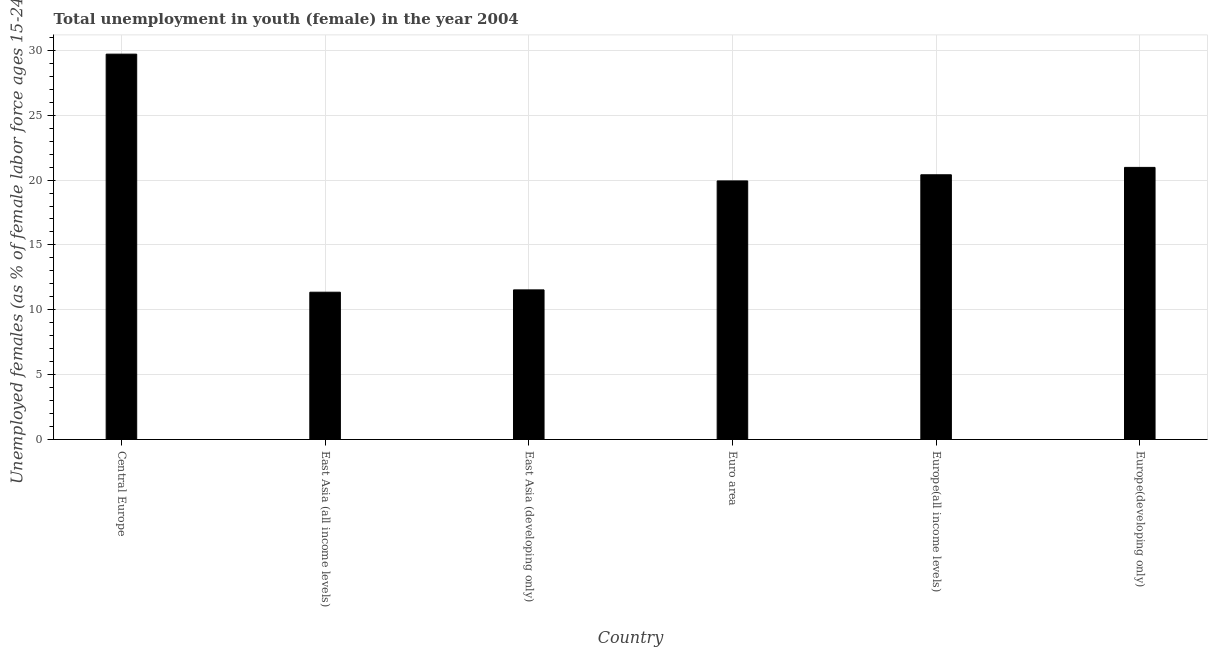What is the title of the graph?
Your answer should be very brief. Total unemployment in youth (female) in the year 2004. What is the label or title of the X-axis?
Ensure brevity in your answer.  Country. What is the label or title of the Y-axis?
Make the answer very short. Unemployed females (as % of female labor force ages 15-24). What is the unemployed female youth population in East Asia (developing only)?
Provide a succinct answer. 11.54. Across all countries, what is the maximum unemployed female youth population?
Your answer should be compact. 29.71. Across all countries, what is the minimum unemployed female youth population?
Provide a short and direct response. 11.36. In which country was the unemployed female youth population maximum?
Your answer should be compact. Central Europe. In which country was the unemployed female youth population minimum?
Offer a terse response. East Asia (all income levels). What is the sum of the unemployed female youth population?
Provide a short and direct response. 113.92. What is the difference between the unemployed female youth population in East Asia (developing only) and Europe(developing only)?
Offer a terse response. -9.44. What is the average unemployed female youth population per country?
Your answer should be compact. 18.99. What is the median unemployed female youth population?
Make the answer very short. 20.17. In how many countries, is the unemployed female youth population greater than 20 %?
Your response must be concise. 3. What is the ratio of the unemployed female youth population in East Asia (developing only) to that in Europe(developing only)?
Make the answer very short. 0.55. Is the difference between the unemployed female youth population in Euro area and Europe(developing only) greater than the difference between any two countries?
Provide a short and direct response. No. What is the difference between the highest and the second highest unemployed female youth population?
Provide a short and direct response. 8.73. What is the difference between the highest and the lowest unemployed female youth population?
Your answer should be very brief. 18.35. In how many countries, is the unemployed female youth population greater than the average unemployed female youth population taken over all countries?
Provide a succinct answer. 4. How many bars are there?
Make the answer very short. 6. Are all the bars in the graph horizontal?
Your answer should be very brief. No. How many countries are there in the graph?
Keep it short and to the point. 6. What is the difference between two consecutive major ticks on the Y-axis?
Your response must be concise. 5. Are the values on the major ticks of Y-axis written in scientific E-notation?
Make the answer very short. No. What is the Unemployed females (as % of female labor force ages 15-24) of Central Europe?
Keep it short and to the point. 29.71. What is the Unemployed females (as % of female labor force ages 15-24) of East Asia (all income levels)?
Keep it short and to the point. 11.36. What is the Unemployed females (as % of female labor force ages 15-24) in East Asia (developing only)?
Offer a very short reply. 11.54. What is the Unemployed females (as % of female labor force ages 15-24) in Euro area?
Your response must be concise. 19.94. What is the Unemployed females (as % of female labor force ages 15-24) of Europe(all income levels)?
Offer a very short reply. 20.41. What is the Unemployed females (as % of female labor force ages 15-24) in Europe(developing only)?
Give a very brief answer. 20.98. What is the difference between the Unemployed females (as % of female labor force ages 15-24) in Central Europe and East Asia (all income levels)?
Your response must be concise. 18.35. What is the difference between the Unemployed females (as % of female labor force ages 15-24) in Central Europe and East Asia (developing only)?
Make the answer very short. 18.17. What is the difference between the Unemployed females (as % of female labor force ages 15-24) in Central Europe and Euro area?
Your answer should be compact. 9.77. What is the difference between the Unemployed females (as % of female labor force ages 15-24) in Central Europe and Europe(all income levels)?
Your answer should be very brief. 9.3. What is the difference between the Unemployed females (as % of female labor force ages 15-24) in Central Europe and Europe(developing only)?
Provide a succinct answer. 8.73. What is the difference between the Unemployed females (as % of female labor force ages 15-24) in East Asia (all income levels) and East Asia (developing only)?
Give a very brief answer. -0.18. What is the difference between the Unemployed females (as % of female labor force ages 15-24) in East Asia (all income levels) and Euro area?
Offer a terse response. -8.58. What is the difference between the Unemployed females (as % of female labor force ages 15-24) in East Asia (all income levels) and Europe(all income levels)?
Keep it short and to the point. -9.05. What is the difference between the Unemployed females (as % of female labor force ages 15-24) in East Asia (all income levels) and Europe(developing only)?
Keep it short and to the point. -9.62. What is the difference between the Unemployed females (as % of female labor force ages 15-24) in East Asia (developing only) and Euro area?
Make the answer very short. -8.4. What is the difference between the Unemployed females (as % of female labor force ages 15-24) in East Asia (developing only) and Europe(all income levels)?
Offer a very short reply. -8.87. What is the difference between the Unemployed females (as % of female labor force ages 15-24) in East Asia (developing only) and Europe(developing only)?
Your answer should be very brief. -9.44. What is the difference between the Unemployed females (as % of female labor force ages 15-24) in Euro area and Europe(all income levels)?
Offer a very short reply. -0.47. What is the difference between the Unemployed females (as % of female labor force ages 15-24) in Euro area and Europe(developing only)?
Keep it short and to the point. -1.04. What is the difference between the Unemployed females (as % of female labor force ages 15-24) in Europe(all income levels) and Europe(developing only)?
Keep it short and to the point. -0.57. What is the ratio of the Unemployed females (as % of female labor force ages 15-24) in Central Europe to that in East Asia (all income levels)?
Offer a terse response. 2.62. What is the ratio of the Unemployed females (as % of female labor force ages 15-24) in Central Europe to that in East Asia (developing only)?
Offer a very short reply. 2.58. What is the ratio of the Unemployed females (as % of female labor force ages 15-24) in Central Europe to that in Euro area?
Offer a very short reply. 1.49. What is the ratio of the Unemployed females (as % of female labor force ages 15-24) in Central Europe to that in Europe(all income levels)?
Give a very brief answer. 1.46. What is the ratio of the Unemployed females (as % of female labor force ages 15-24) in Central Europe to that in Europe(developing only)?
Give a very brief answer. 1.42. What is the ratio of the Unemployed females (as % of female labor force ages 15-24) in East Asia (all income levels) to that in East Asia (developing only)?
Ensure brevity in your answer.  0.98. What is the ratio of the Unemployed females (as % of female labor force ages 15-24) in East Asia (all income levels) to that in Euro area?
Provide a short and direct response. 0.57. What is the ratio of the Unemployed females (as % of female labor force ages 15-24) in East Asia (all income levels) to that in Europe(all income levels)?
Offer a terse response. 0.56. What is the ratio of the Unemployed females (as % of female labor force ages 15-24) in East Asia (all income levels) to that in Europe(developing only)?
Offer a very short reply. 0.54. What is the ratio of the Unemployed females (as % of female labor force ages 15-24) in East Asia (developing only) to that in Euro area?
Give a very brief answer. 0.58. What is the ratio of the Unemployed females (as % of female labor force ages 15-24) in East Asia (developing only) to that in Europe(all income levels)?
Your response must be concise. 0.56. What is the ratio of the Unemployed females (as % of female labor force ages 15-24) in East Asia (developing only) to that in Europe(developing only)?
Your response must be concise. 0.55. What is the ratio of the Unemployed females (as % of female labor force ages 15-24) in Euro area to that in Europe(all income levels)?
Provide a short and direct response. 0.98. What is the ratio of the Unemployed females (as % of female labor force ages 15-24) in Europe(all income levels) to that in Europe(developing only)?
Your answer should be very brief. 0.97. 